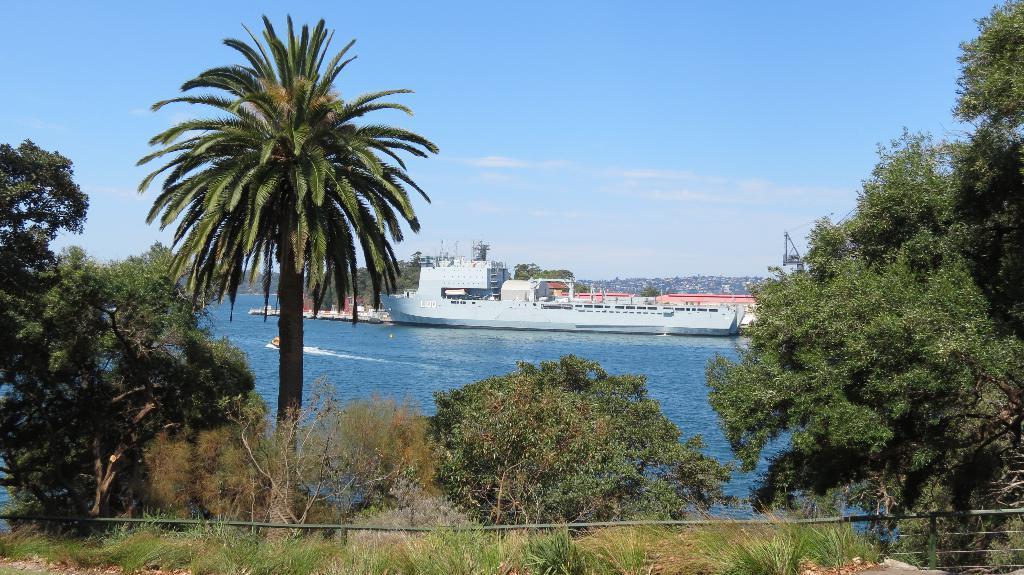In one or two sentences, can you explain what this image depicts? In the foreground of this image, there is grass and trees. In the middle, there is water and a ship on it. Behind it, it seems like a dock. In the background, there is city, sky and the cloud. 